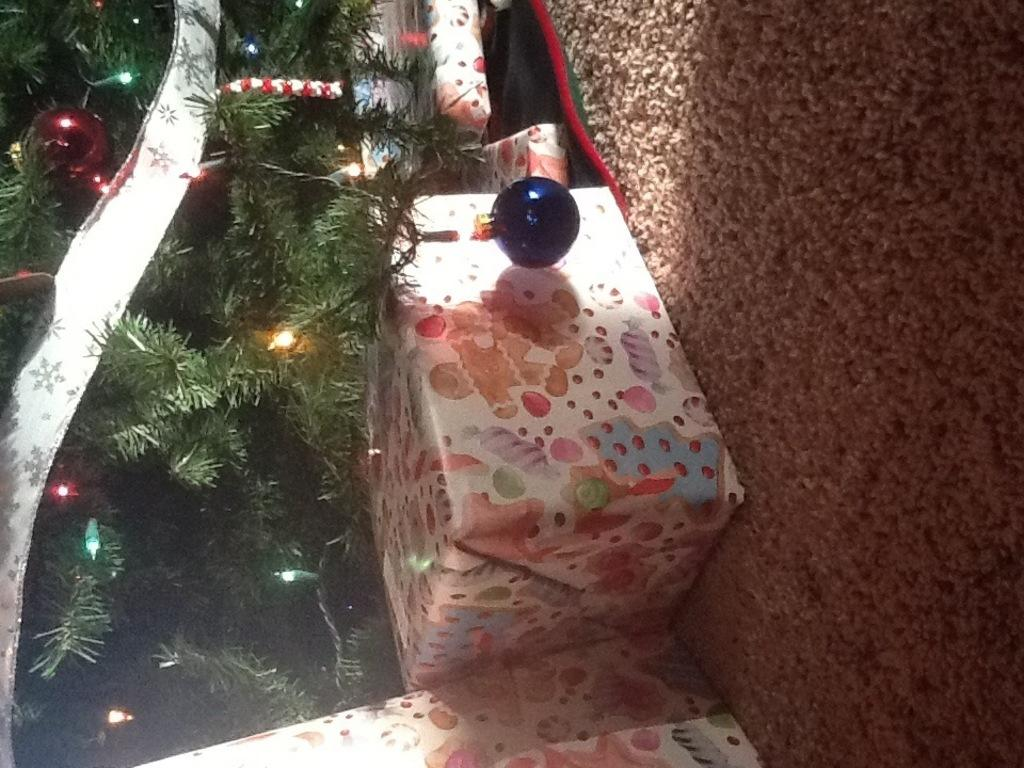What type of trees are on the left side of the image? There are Christmas trees on the left side of the image. What is placed in front of the Christmas trees? There are gifts in front of the Christmas trees. What can be seen illuminating the scene in the image? There are lights visible in the image. What is at the bottom of the image? There is a road at the bottom of the image. What type of plastic is used to make the stew in the image? There is no stew present in the image, and therefore no plastic is involved. 